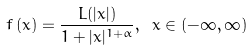Convert formula to latex. <formula><loc_0><loc_0><loc_500><loc_500>f \left ( x \right ) = \frac { L ( | x | ) } { 1 + | x | ^ { 1 + \alpha } } , \ x \in ( - \infty , \infty )</formula> 